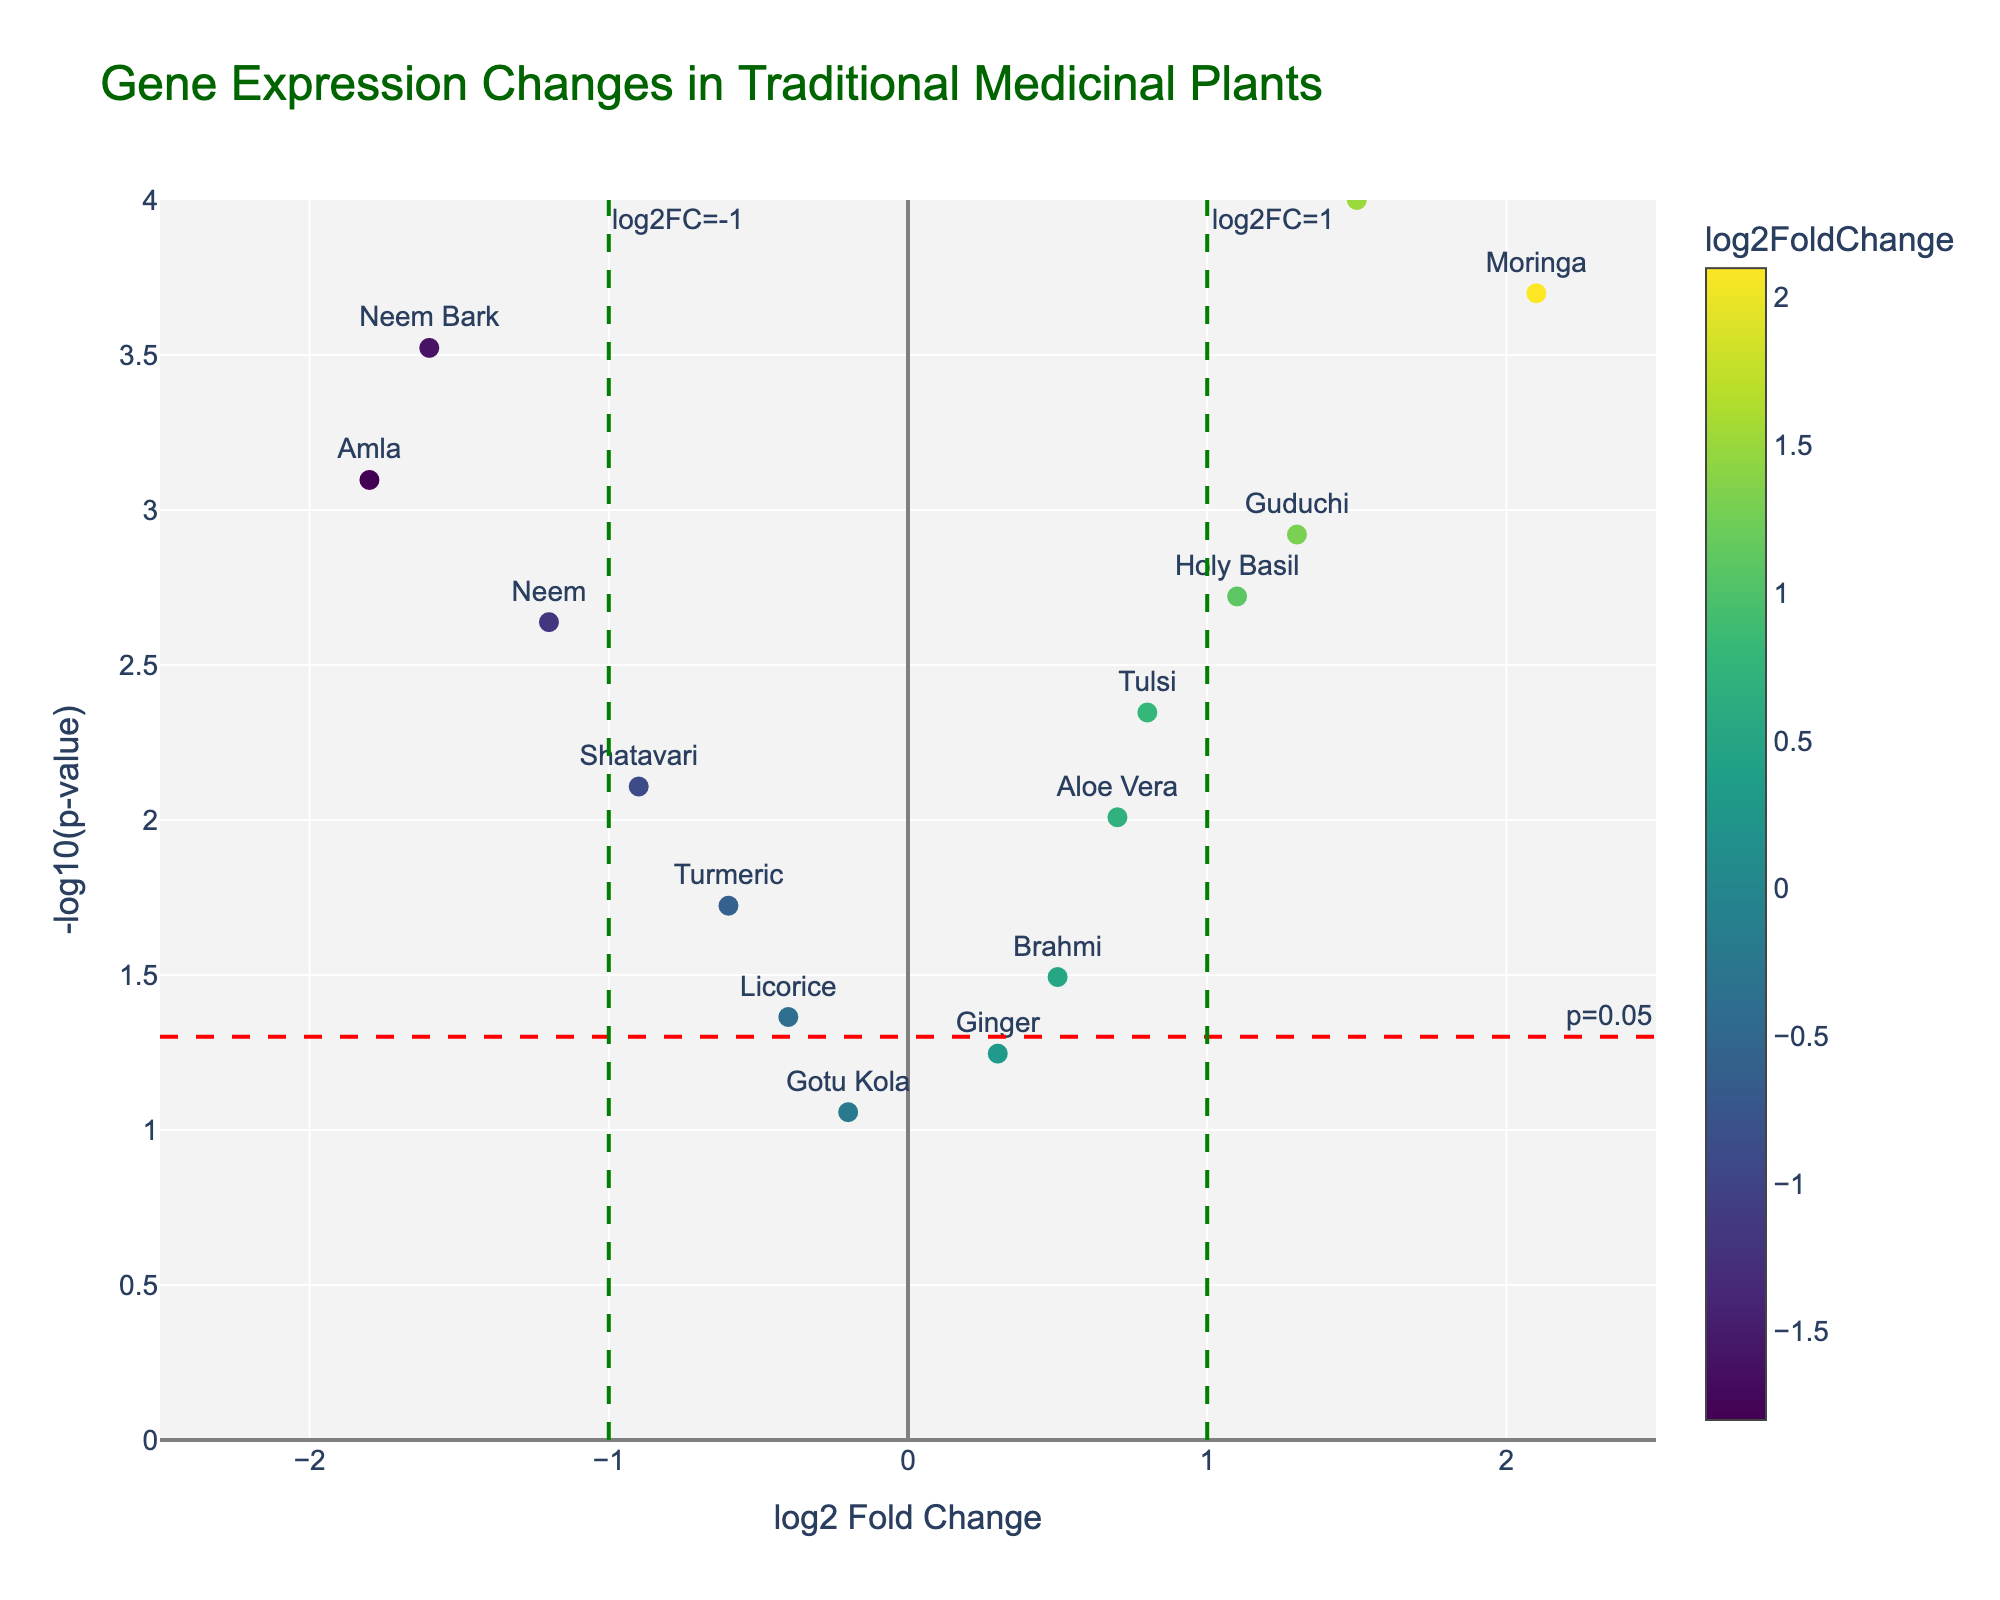What is the title of the figure? The title can be found at the top of the figure and provides an overview of what the chart represents. It states: "Gene Expression Changes in Traditional Medicinal Plants".
Answer: Gene Expression Changes in Traditional Medicinal Plants How many genes have a log2 fold change greater than or equal to 1? Look at the x-axis values and count the number of points to the right of or at the 1 mark. Here, the genes are Ashwagandha, Moringa, Guduchi, and Holy Basil.
Answer: 4 Which gene has the highest -log10(p-value)? Find the point with the highest y-axis value. The gene with the highest -log10(p-value) here is Ashwagandha.
Answer: Ashwagandha Are there any genes with a log2 fold change less than -1 and a -log10(p-value) greater than 3? Look for points that are to the left of the -1 mark on the x-axis and above the 3 mark on the y-axis. Neem Bark fits these criteria.
Answer: Neem Bark Which gene has the highest downward fold change in expression? Downward fold change implies a negative log2 fold change. Look for the most leftward point on the x-axis. Here it is Amla.
Answer: Amla Is there a gene with a p-value greater than 0.05 indicated on the plot? The p-value greater than 0.05 would have a -log10(p-value) less than 1. All genes shown have a -log10(p-value) above this threshold, so there are no such genes.
Answer: No Which genes show a statistically significant positive expression change, considering p < 0.05 and log2FC > 0? Points to the right of the y-axis (log2FC > 0) and above the horizontal red line (p < 0.05) show significant positive expression changes. These are Tulsi, Ashwagandha, Moringa, Guduchi, Holy Basil, and Aloe Vera.
Answer: Tulsi, Ashwagandha, Moringa, Guduchi, Holy Basil, and Aloe Vera What is the median -log10(p-value) for the genes shown on the plot? Sort the -log10(p-value) values and find the middle one. The values are roughly 2, 1.9, 0.2, etc. Assuming no exact values without calculation, a visual middle would be around 2.
Answer: Around 2 Which gene has the smallest absolute change in expression? Look for the point closest to the y-axis (log2 fold change closest to 0). Gotu Kola is the closest.
Answer: Gotu Kola 